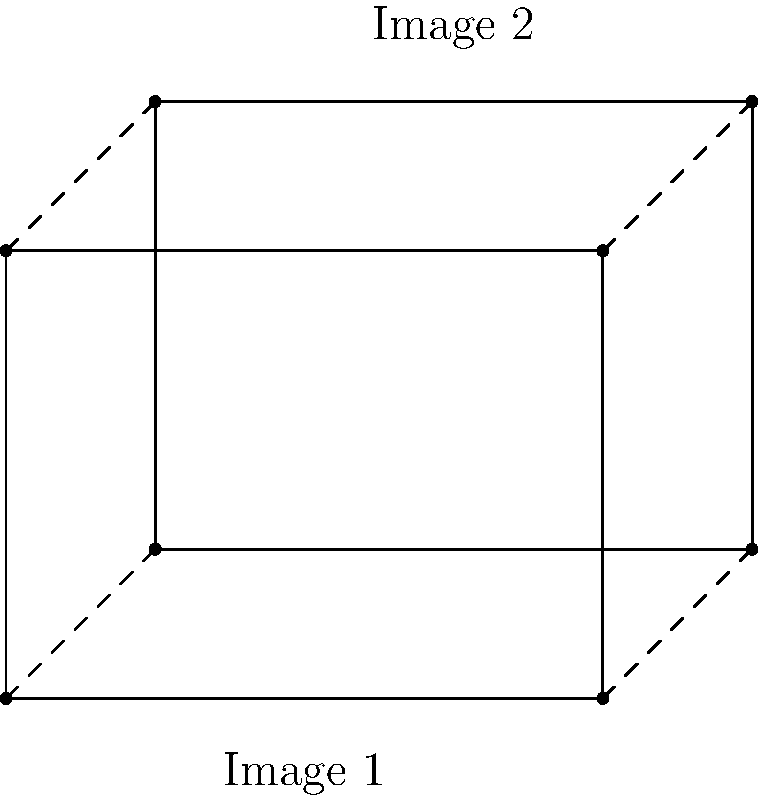In the context of image registration for panorama creation, what geometric transformation is represented by the relationship between Image 1 and Image 2 in the diagram? How would you describe the transformation parameters? To determine the geometric transformation and its parameters, we need to analyze the relationship between Image 1 and Image 2:

1. Observe that the shape and size of both images are preserved, indicating that the transformation maintains parallel lines and angles.

2. Notice that Image 2 is shifted relative to Image 1 both horizontally and vertically.

3. There is no rotation or scaling between the two images.

These observations lead us to conclude that the transformation is a translation.

To describe the transformation parameters:

1. Calculate the horizontal shift:
   $\Delta x = x_2 - x_1 = 1 - 0 = 1$ unit to the right

2. Calculate the vertical shift:
   $\Delta y = y_2 - y_1 = 1 - 0 = 1$ unit upward

Therefore, the transformation can be described as a translation with parameters $(t_x, t_y) = (1, 1)$, where $t_x$ represents the horizontal translation and $t_y$ represents the vertical translation.

In matrix form, this translation can be expressed as:

$$
\begin{bmatrix}
x' \\
y' \\
1
\end{bmatrix} = 
\begin{bmatrix}
1 & 0 & 1 \\
0 & 1 & 1 \\
0 & 0 & 1
\end{bmatrix}
\begin{bmatrix}
x \\
y \\
1
\end{bmatrix}
$$

Where $(x, y)$ are coordinates in Image 1 and $(x', y')$ are the corresponding coordinates in Image 2.
Answer: Translation with parameters $(t_x, t_y) = (1, 1)$ 